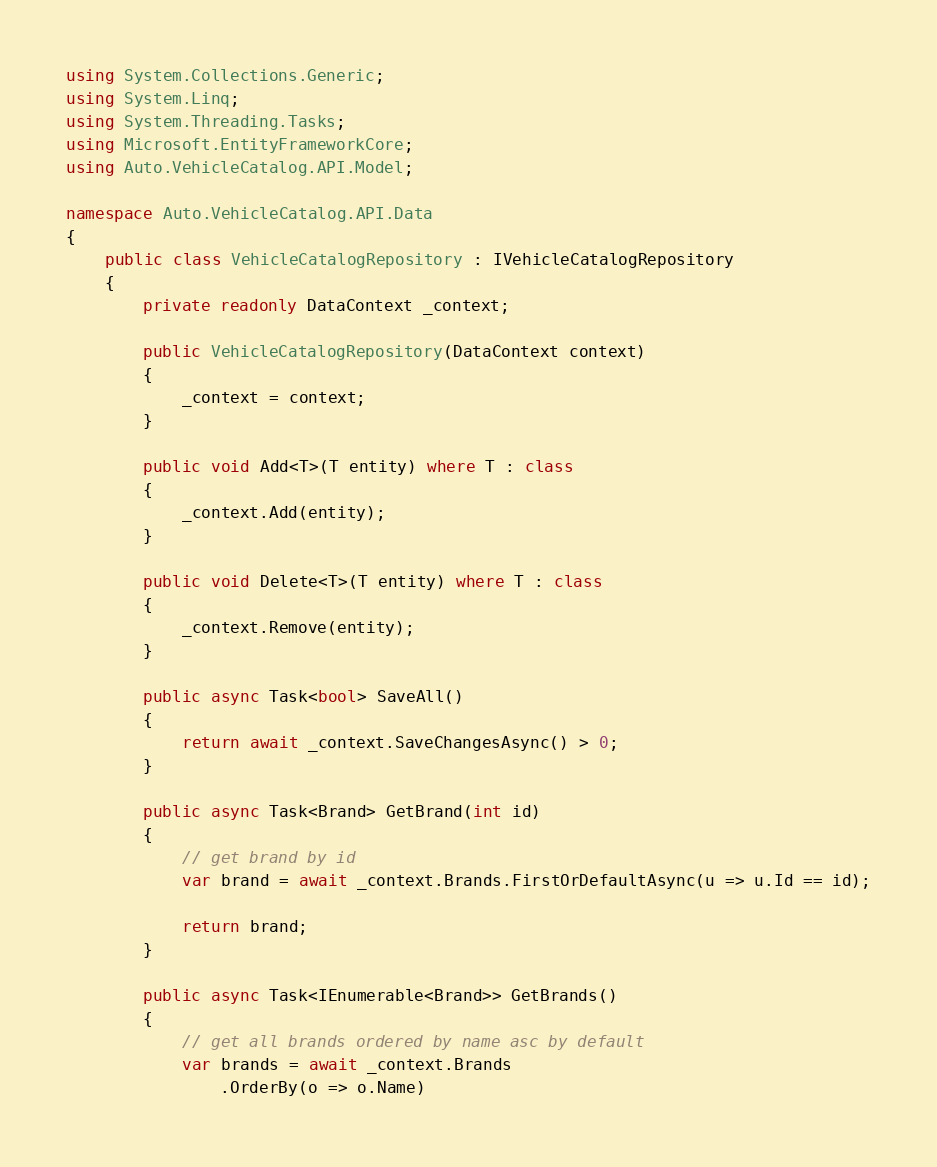Convert code to text. <code><loc_0><loc_0><loc_500><loc_500><_C#_>using System.Collections.Generic;
using System.Linq;
using System.Threading.Tasks;
using Microsoft.EntityFrameworkCore;
using Auto.VehicleCatalog.API.Model;

namespace Auto.VehicleCatalog.API.Data
{
    public class VehicleCatalogRepository : IVehicleCatalogRepository
    {
        private readonly DataContext _context;

        public VehicleCatalogRepository(DataContext context)
        {
            _context = context;
        }

        public void Add<T>(T entity) where T : class
        {
            _context.Add(entity);
        }

        public void Delete<T>(T entity) where T : class
        {
            _context.Remove(entity);
        }

        public async Task<bool> SaveAll()
        {
            return await _context.SaveChangesAsync() > 0;
        }

        public async Task<Brand> GetBrand(int id)
        {
            // get brand by id
            var brand = await _context.Brands.FirstOrDefaultAsync(u => u.Id == id);

            return brand;
        }

        public async Task<IEnumerable<Brand>> GetBrands()
        {
            // get all brands ordered by name asc by default
            var brands = await _context.Brands
                .OrderBy(o => o.Name)</code> 